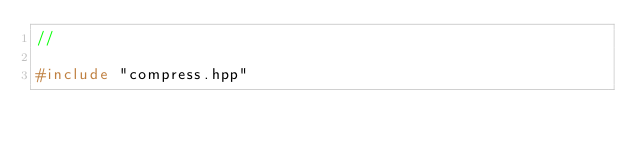<code> <loc_0><loc_0><loc_500><loc_500><_C++_>//

#include "compress.hpp"
</code> 